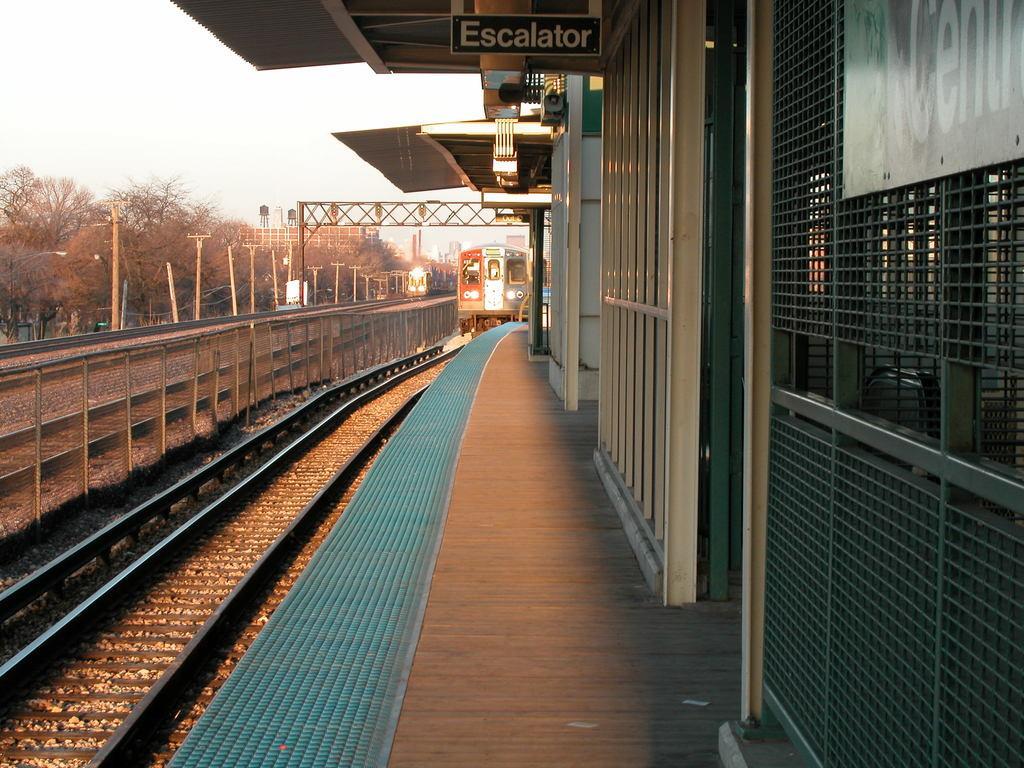Please provide a concise description of this image. In this picture there is a platform on the right side of the image and there are roofs and a escalator board at the top side of the image and there are trees, poles, buildings, and trains on the tracks in the background area of the image. 